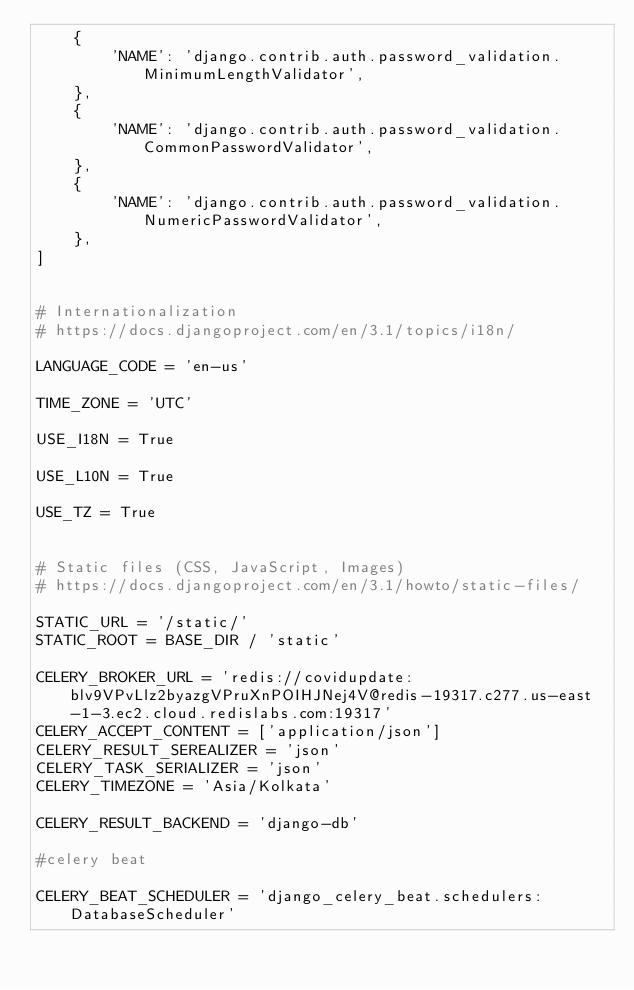<code> <loc_0><loc_0><loc_500><loc_500><_Python_>    {
        'NAME': 'django.contrib.auth.password_validation.MinimumLengthValidator',
    },
    {
        'NAME': 'django.contrib.auth.password_validation.CommonPasswordValidator',
    },
    {
        'NAME': 'django.contrib.auth.password_validation.NumericPasswordValidator',
    },
]


# Internationalization
# https://docs.djangoproject.com/en/3.1/topics/i18n/

LANGUAGE_CODE = 'en-us'

TIME_ZONE = 'UTC'

USE_I18N = True

USE_L10N = True

USE_TZ = True


# Static files (CSS, JavaScript, Images)
# https://docs.djangoproject.com/en/3.1/howto/static-files/

STATIC_URL = '/static/'
STATIC_ROOT = BASE_DIR / 'static'

CELERY_BROKER_URL = 'redis://covidupdate:blv9VPvLlz2byazgVPruXnPOIHJNej4V@redis-19317.c277.us-east-1-3.ec2.cloud.redislabs.com:19317'
CELERY_ACCEPT_CONTENT = ['application/json']
CELERY_RESULT_SEREALIZER = 'json'
CELERY_TASK_SERIALIZER = 'json'
CELERY_TIMEZONE = 'Asia/Kolkata'

CELERY_RESULT_BACKEND = 'django-db'

#celery beat

CELERY_BEAT_SCHEDULER = 'django_celery_beat.schedulers:DatabaseScheduler'</code> 